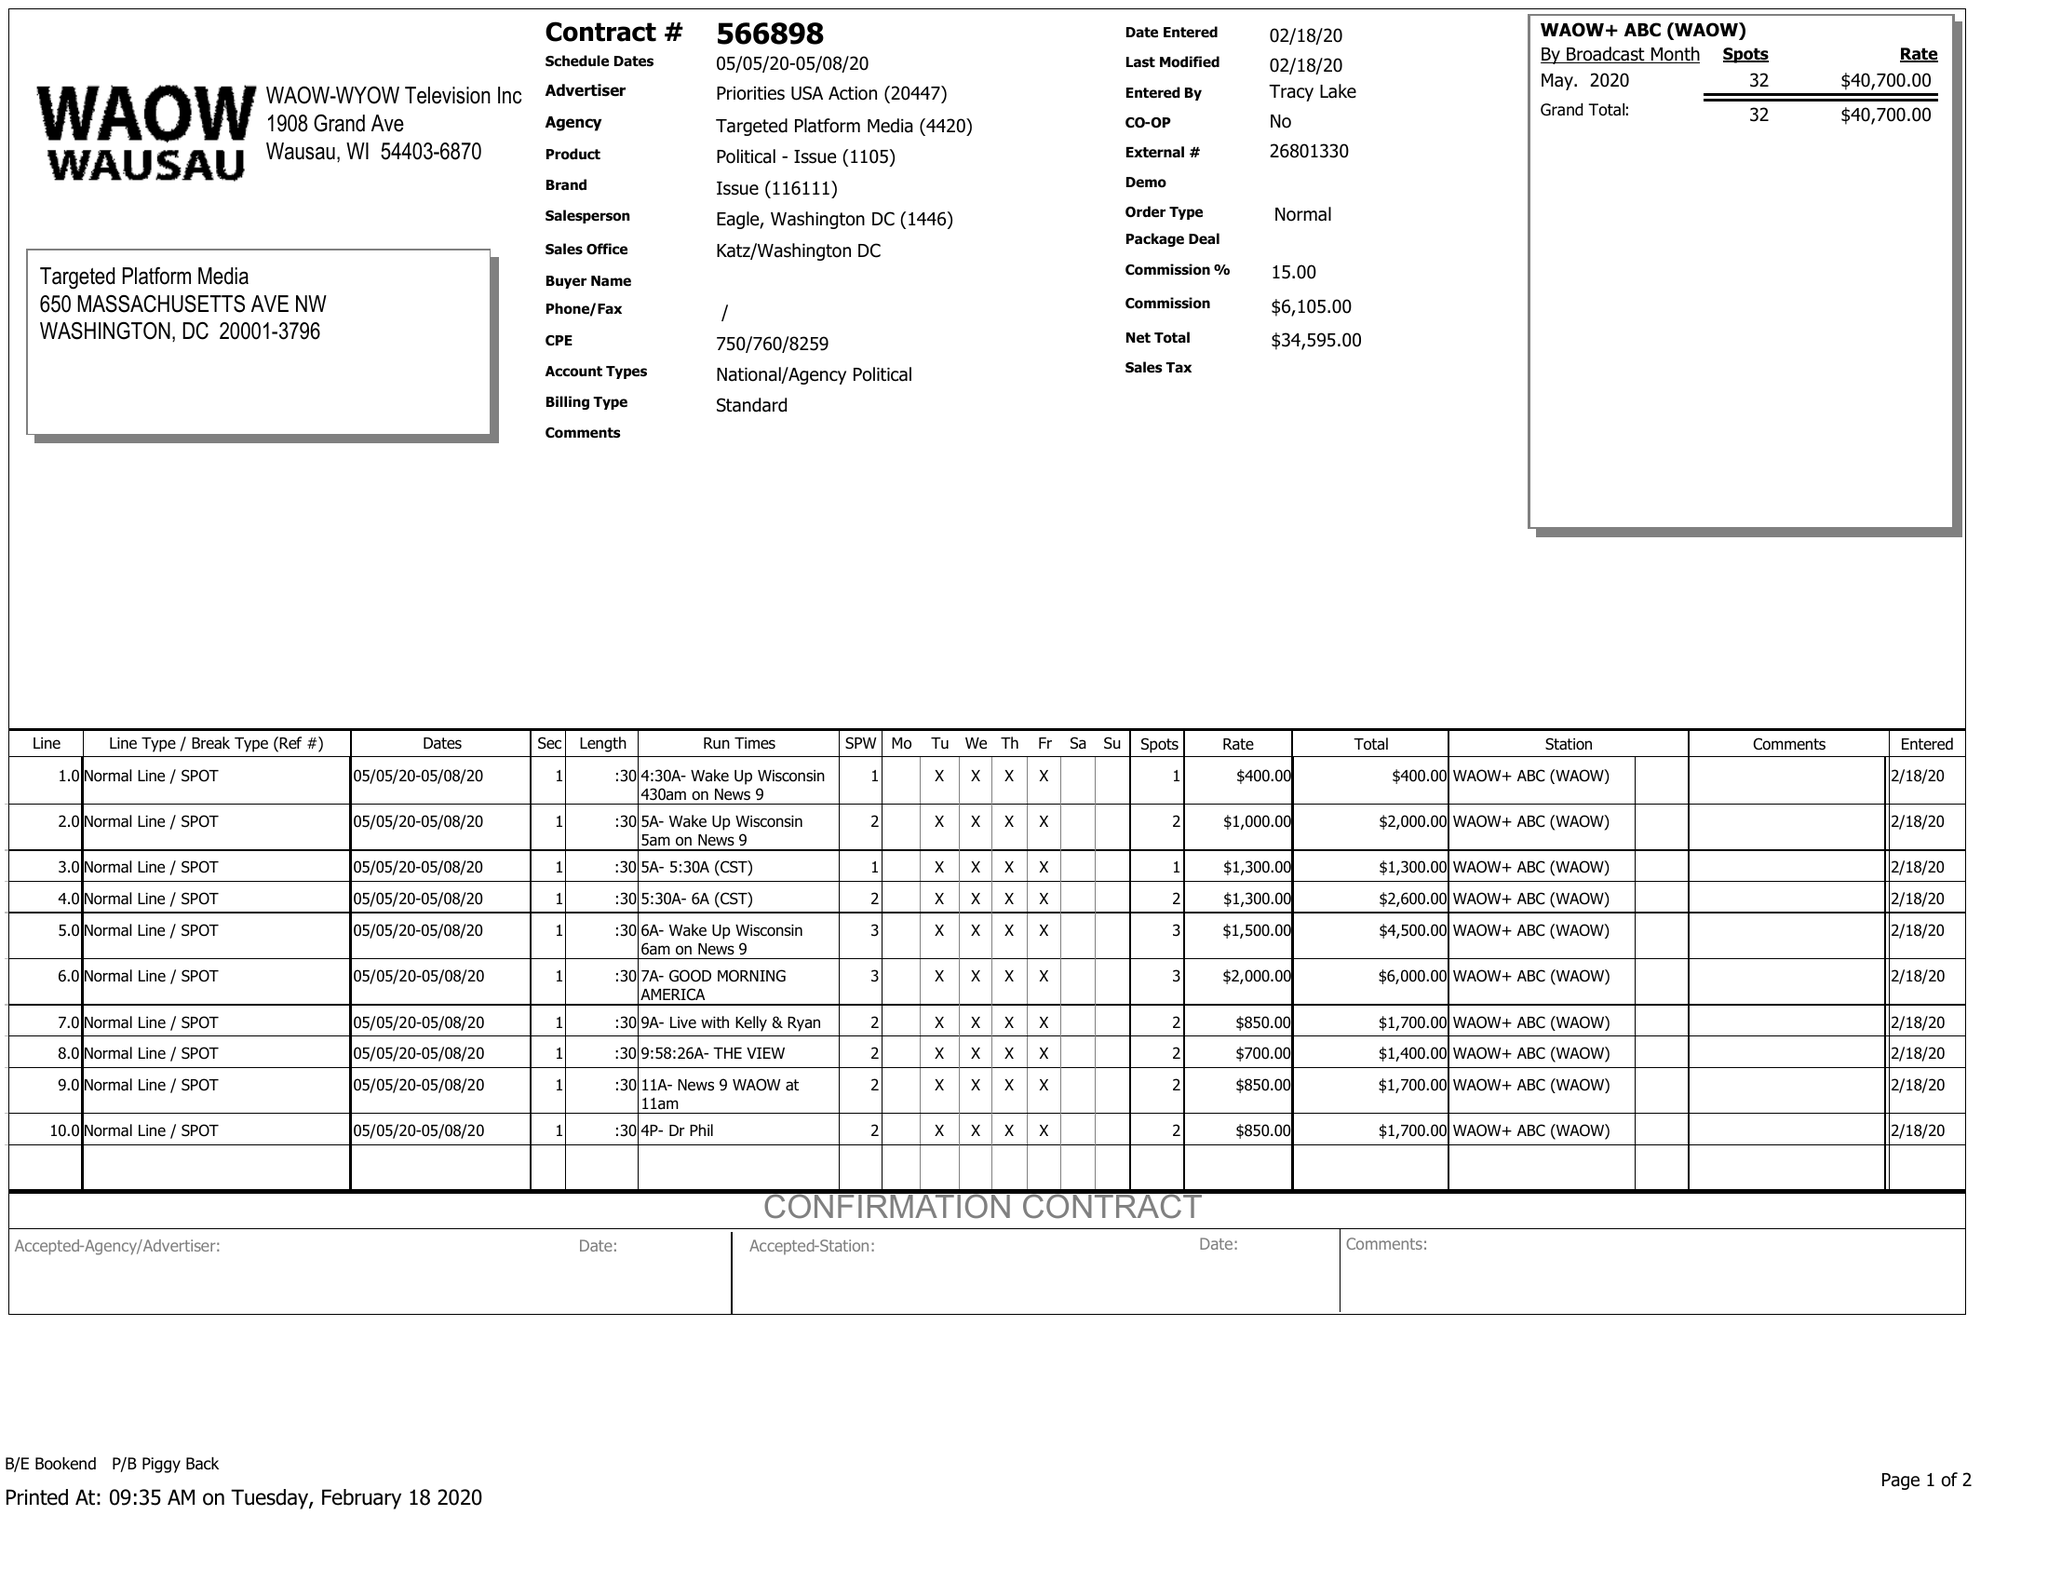What is the value for the flight_from?
Answer the question using a single word or phrase. 05/05/20 